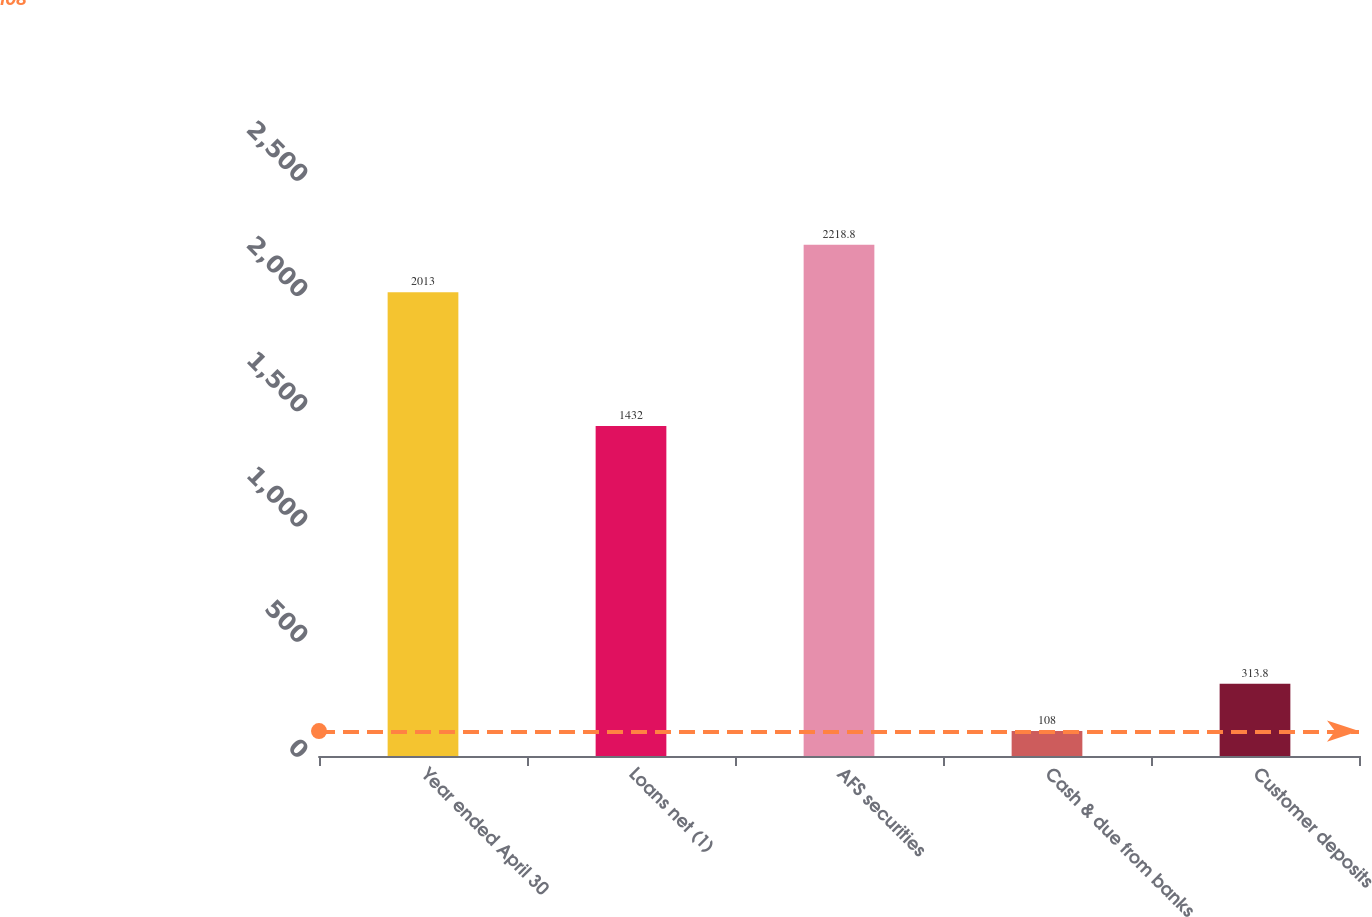Convert chart to OTSL. <chart><loc_0><loc_0><loc_500><loc_500><bar_chart><fcel>Year ended April 30<fcel>Loans net (1)<fcel>AFS securities<fcel>Cash & due from banks<fcel>Customer deposits<nl><fcel>2013<fcel>1432<fcel>2218.8<fcel>108<fcel>313.8<nl></chart> 